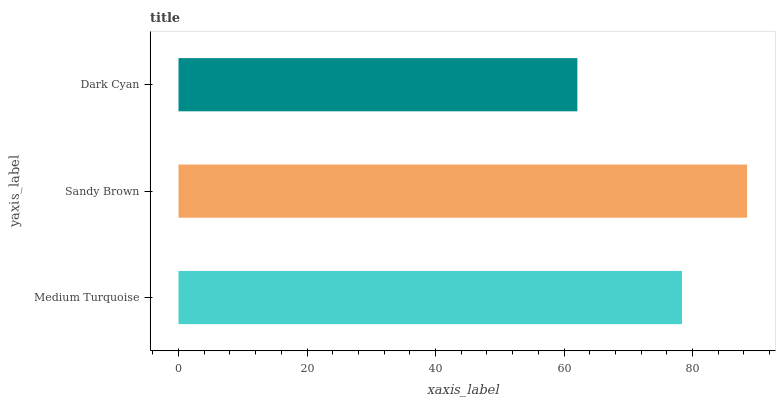Is Dark Cyan the minimum?
Answer yes or no. Yes. Is Sandy Brown the maximum?
Answer yes or no. Yes. Is Sandy Brown the minimum?
Answer yes or no. No. Is Dark Cyan the maximum?
Answer yes or no. No. Is Sandy Brown greater than Dark Cyan?
Answer yes or no. Yes. Is Dark Cyan less than Sandy Brown?
Answer yes or no. Yes. Is Dark Cyan greater than Sandy Brown?
Answer yes or no. No. Is Sandy Brown less than Dark Cyan?
Answer yes or no. No. Is Medium Turquoise the high median?
Answer yes or no. Yes. Is Medium Turquoise the low median?
Answer yes or no. Yes. Is Dark Cyan the high median?
Answer yes or no. No. Is Sandy Brown the low median?
Answer yes or no. No. 